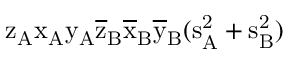<formula> <loc_0><loc_0><loc_500><loc_500>z _ { A } \mathrm { x _ { A } \mathrm { y _ { A } \mathrm { \overline { z } _ { B } \mathrm { \overline { x } _ { B } \mathrm { \overline { y } _ { B } ( \mathrm { s _ { A } ^ { 2 } + \mathrm { s _ { B } ^ { 2 } ) } } } } } } }</formula> 